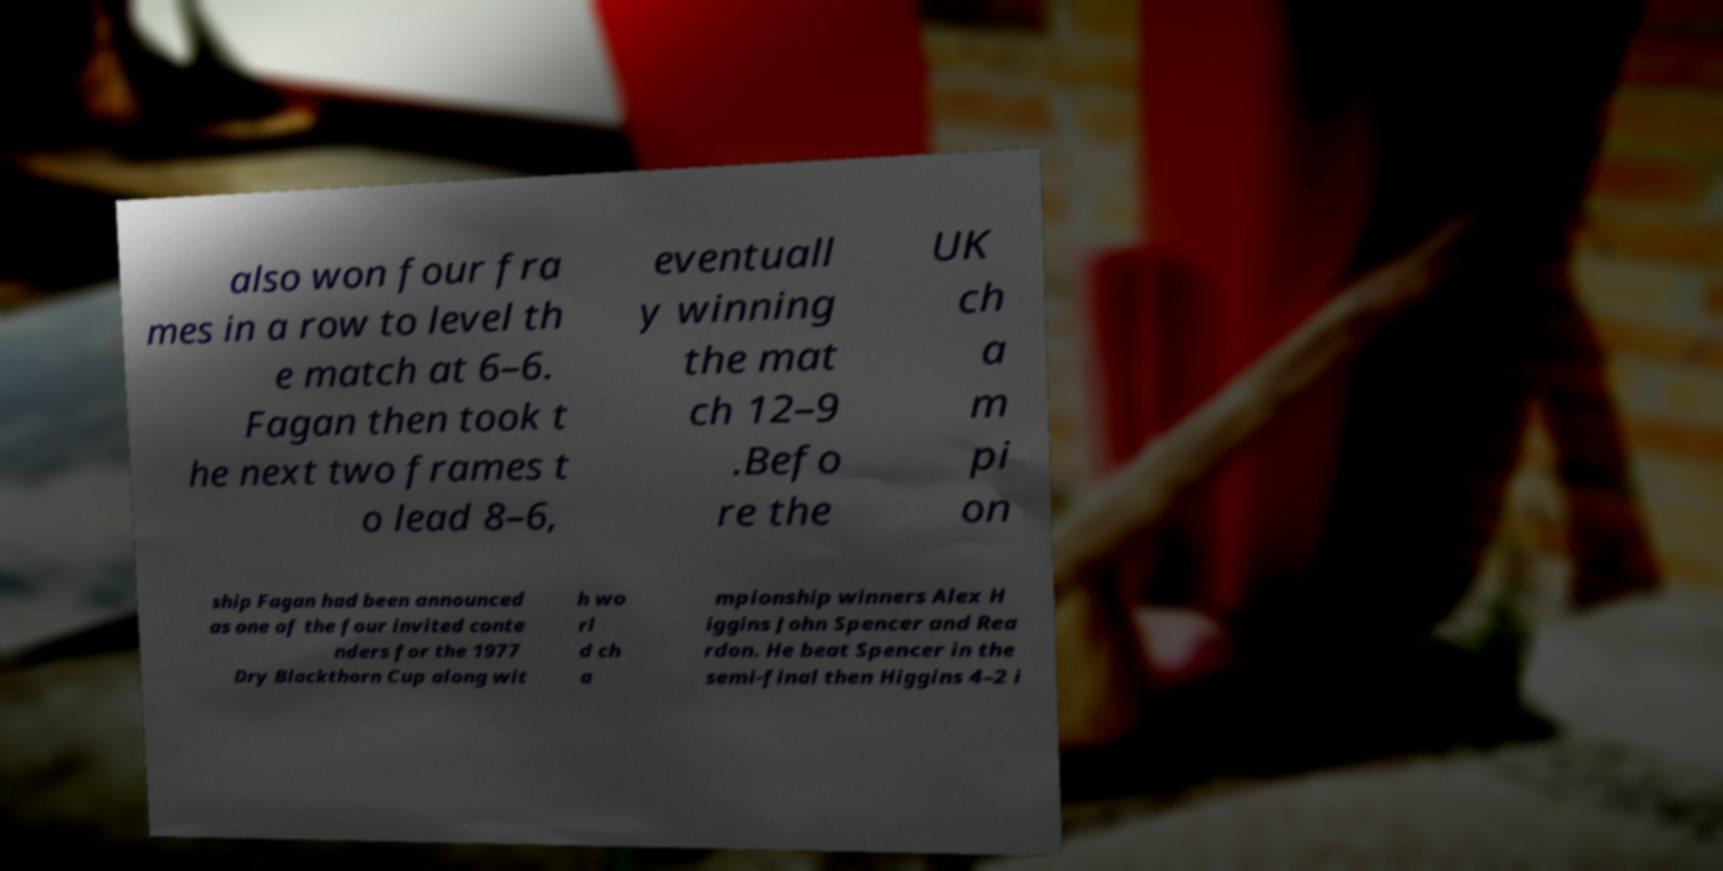Please identify and transcribe the text found in this image. also won four fra mes in a row to level th e match at 6–6. Fagan then took t he next two frames t o lead 8–6, eventuall y winning the mat ch 12–9 .Befo re the UK ch a m pi on ship Fagan had been announced as one of the four invited conte nders for the 1977 Dry Blackthorn Cup along wit h wo rl d ch a mpionship winners Alex H iggins John Spencer and Rea rdon. He beat Spencer in the semi-final then Higgins 4–2 i 